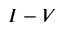<formula> <loc_0><loc_0><loc_500><loc_500>I - V</formula> 